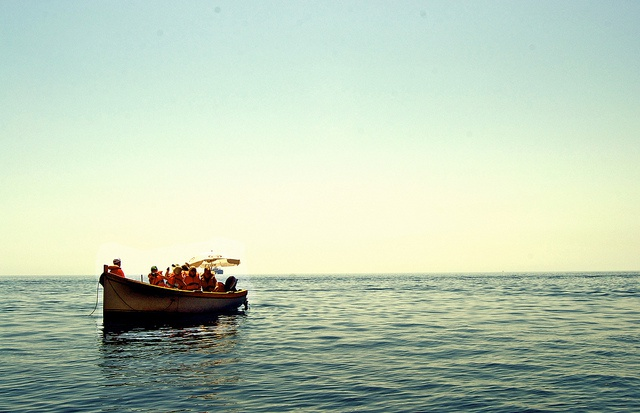Describe the objects in this image and their specific colors. I can see boat in lightblue, black, maroon, beige, and olive tones, umbrella in lightblue, lightyellow, khaki, olive, and tan tones, people in lightblue, maroon, black, and brown tones, people in lightblue, black, maroon, beige, and olive tones, and people in lightblue, maroon, black, and brown tones in this image. 